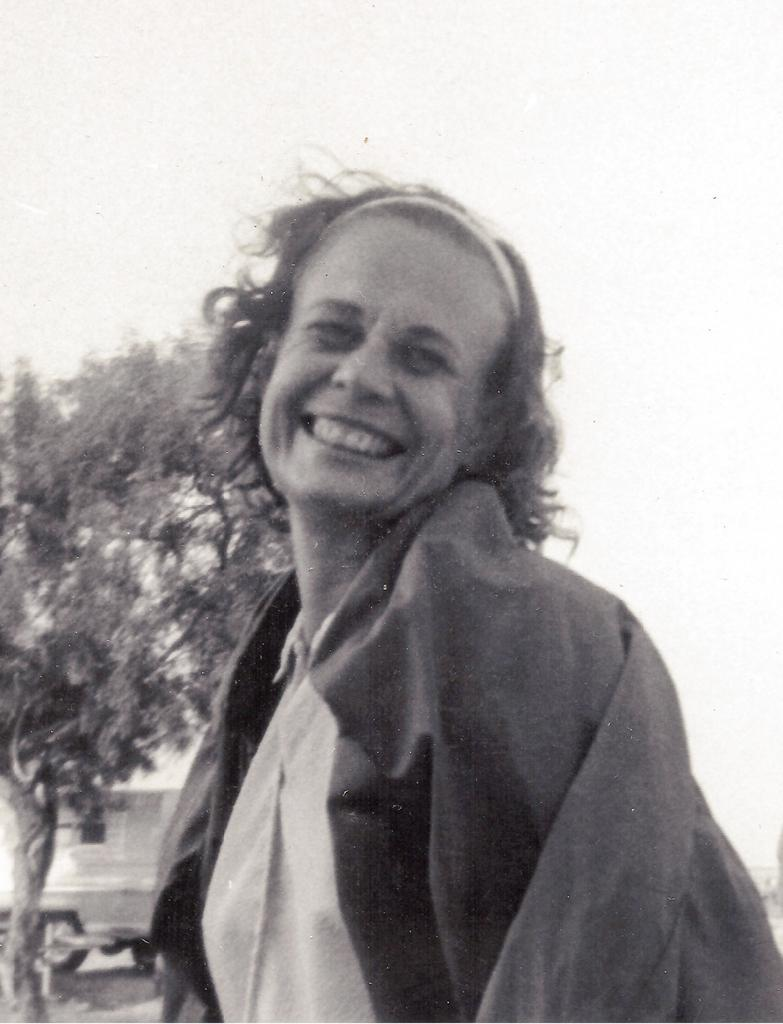What is the color scheme of the image? The image is black and white. Who is the main subject in the image? There is a lady in the center of the image. What is the lady wearing? The lady is wearing a jacket. What can be seen in the background of the image? There is a tree in the background of the image. What type of mint can be seen growing near the tree in the image? There is no mint visible in the image; it only features a lady and a tree in a black and white setting. 